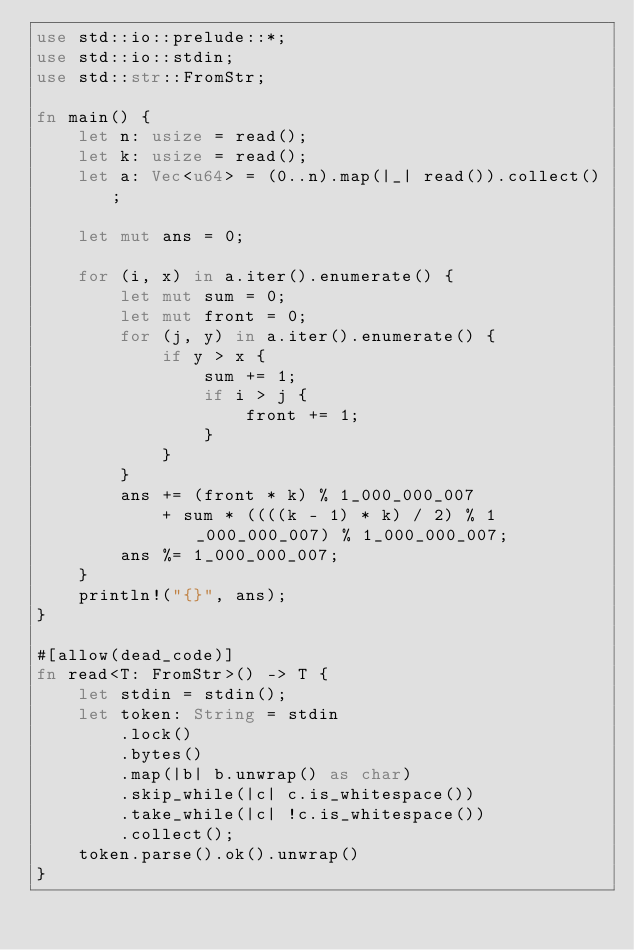Convert code to text. <code><loc_0><loc_0><loc_500><loc_500><_Rust_>use std::io::prelude::*;
use std::io::stdin;
use std::str::FromStr;

fn main() {
    let n: usize = read();
    let k: usize = read();
    let a: Vec<u64> = (0..n).map(|_| read()).collect();

    let mut ans = 0;

    for (i, x) in a.iter().enumerate() {
        let mut sum = 0;
        let mut front = 0;
        for (j, y) in a.iter().enumerate() {
            if y > x {
                sum += 1;
                if i > j {
                    front += 1;
                }
            }
        }
        ans += (front * k) % 1_000_000_007
            + sum * ((((k - 1) * k) / 2) % 1_000_000_007) % 1_000_000_007;
        ans %= 1_000_000_007;
    }
    println!("{}", ans);
}

#[allow(dead_code)]
fn read<T: FromStr>() -> T {
    let stdin = stdin();
    let token: String = stdin
        .lock()
        .bytes()
        .map(|b| b.unwrap() as char)
        .skip_while(|c| c.is_whitespace())
        .take_while(|c| !c.is_whitespace())
        .collect();
    token.parse().ok().unwrap()
}
</code> 